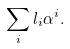Convert formula to latex. <formula><loc_0><loc_0><loc_500><loc_500>\sum _ { i } l _ { i } \alpha ^ { i } .</formula> 